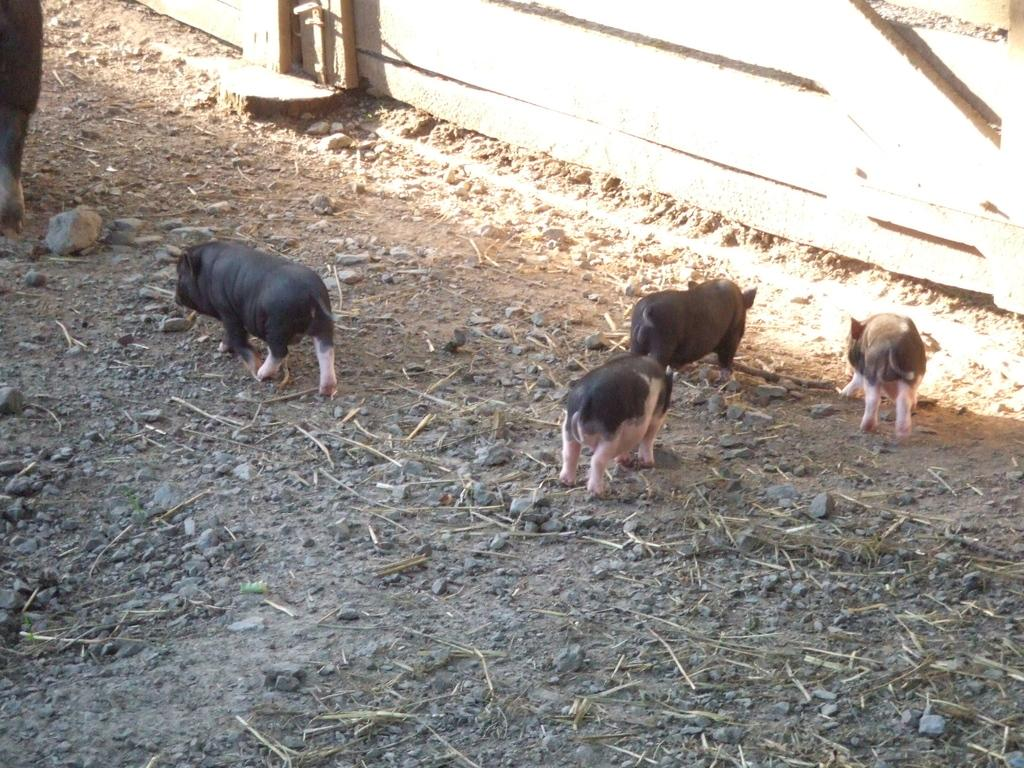What animals are present in the image? There is a group of pigs in the image. Where are the pigs located? A: The pigs are present on the ground. What can be seen on the right side of the image? There is wooden railing on the right side of the image. How much chalk is present in the image? There is no chalk present in the image. 